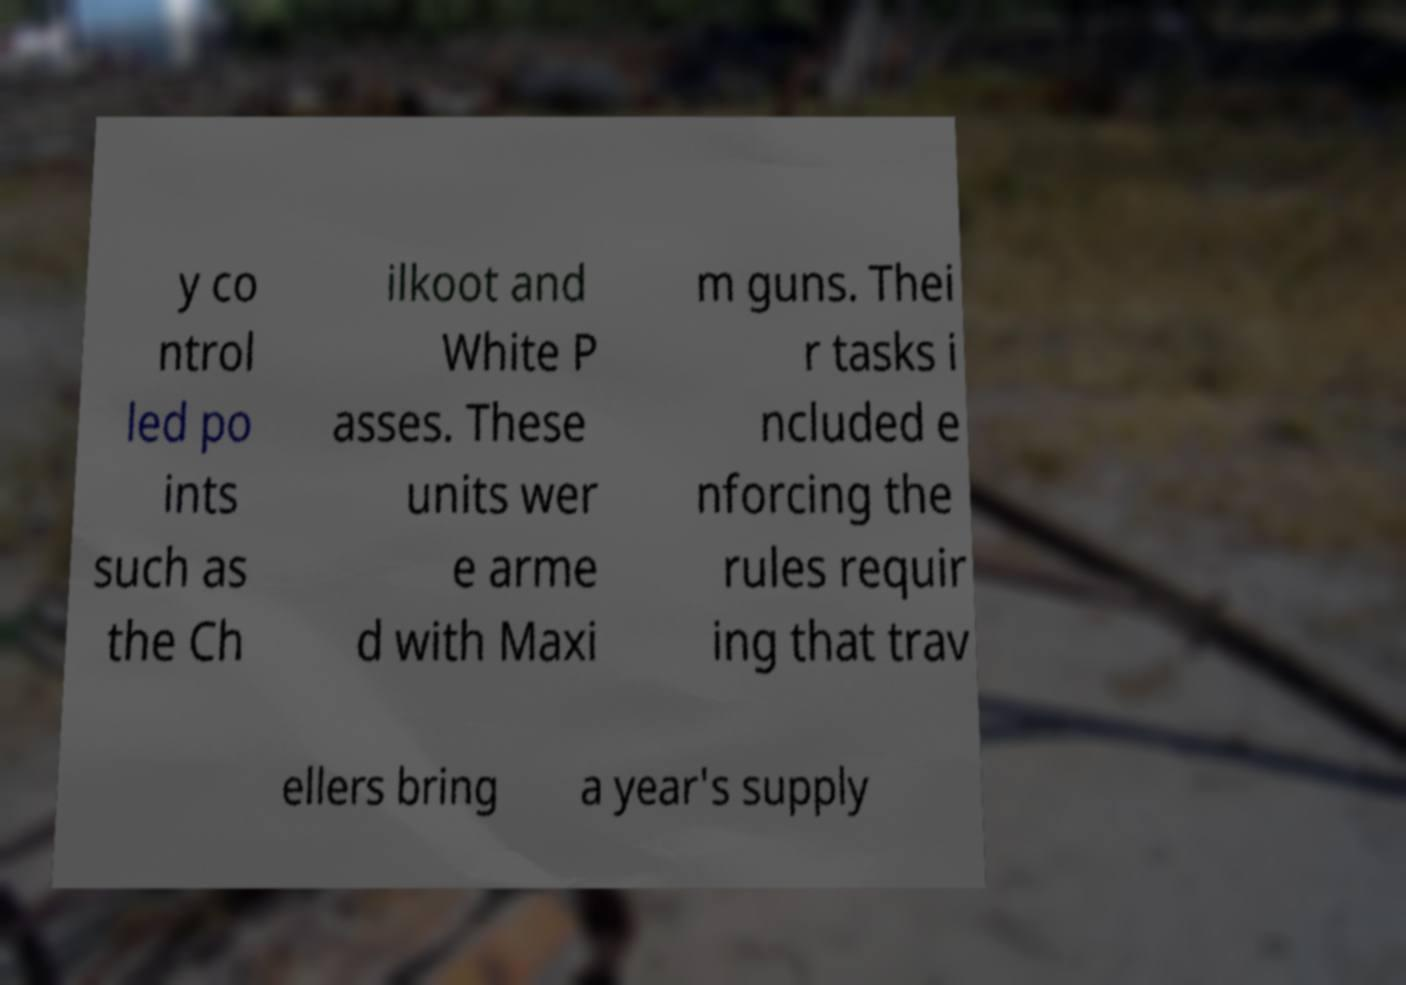What messages or text are displayed in this image? I need them in a readable, typed format. y co ntrol led po ints such as the Ch ilkoot and White P asses. These units wer e arme d with Maxi m guns. Thei r tasks i ncluded e nforcing the rules requir ing that trav ellers bring a year's supply 